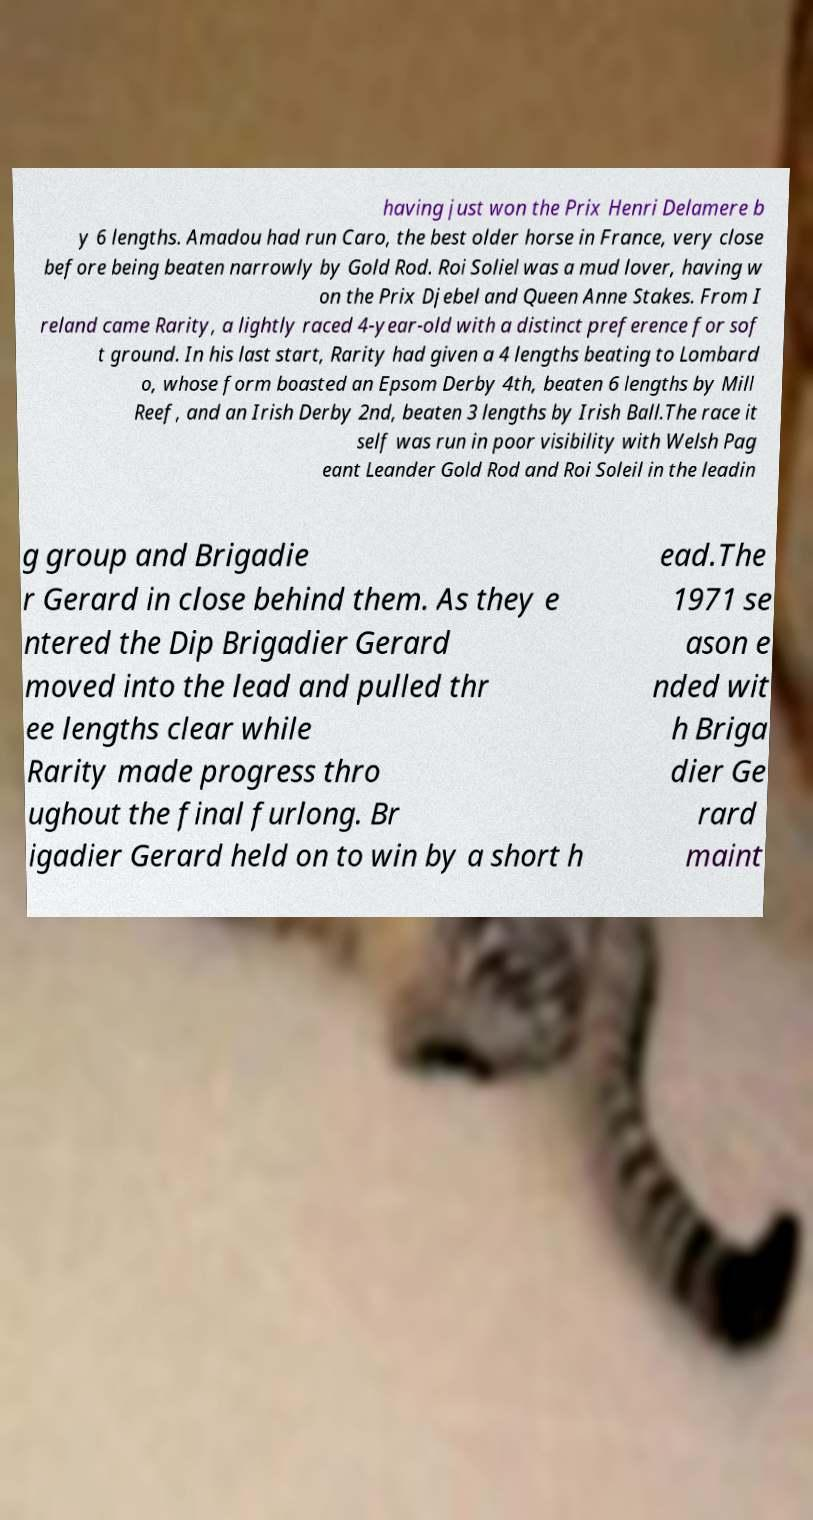What messages or text are displayed in this image? I need them in a readable, typed format. having just won the Prix Henri Delamere b y 6 lengths. Amadou had run Caro, the best older horse in France, very close before being beaten narrowly by Gold Rod. Roi Soliel was a mud lover, having w on the Prix Djebel and Queen Anne Stakes. From I reland came Rarity, a lightly raced 4-year-old with a distinct preference for sof t ground. In his last start, Rarity had given a 4 lengths beating to Lombard o, whose form boasted an Epsom Derby 4th, beaten 6 lengths by Mill Reef, and an Irish Derby 2nd, beaten 3 lengths by Irish Ball.The race it self was run in poor visibility with Welsh Pag eant Leander Gold Rod and Roi Soleil in the leadin g group and Brigadie r Gerard in close behind them. As they e ntered the Dip Brigadier Gerard moved into the lead and pulled thr ee lengths clear while Rarity made progress thro ughout the final furlong. Br igadier Gerard held on to win by a short h ead.The 1971 se ason e nded wit h Briga dier Ge rard maint 